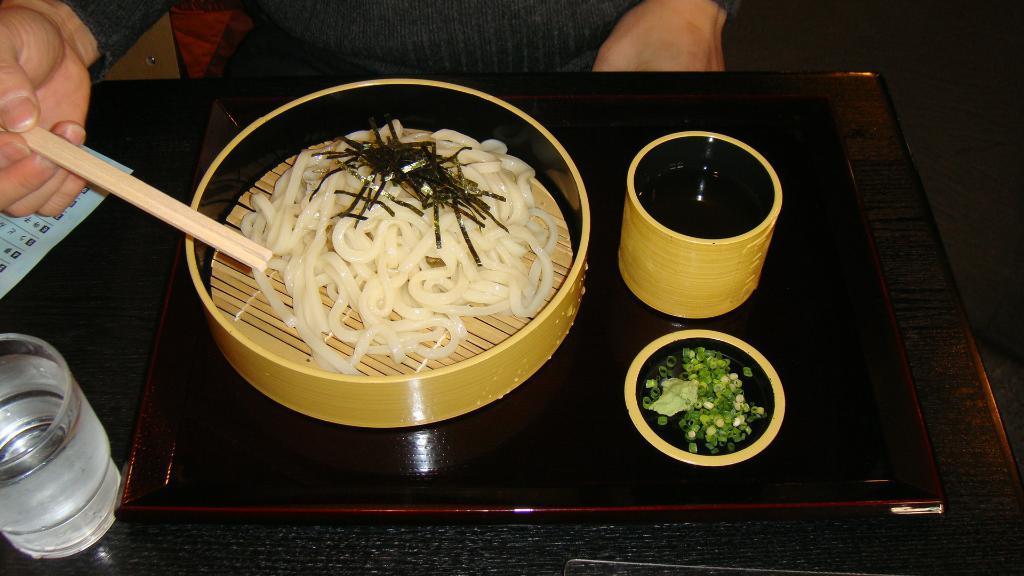How would you summarize this image in a sentence or two? This is the picture of a table on which there is a glass, bowl which has some food item and also some other things to the side. 